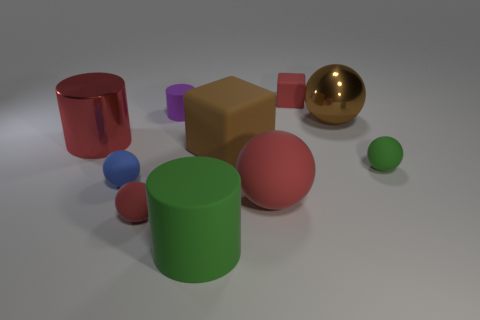There is a green matte object that is on the left side of the matte block that is in front of the big red cylinder; what is its size?
Your response must be concise. Large. Is there another matte sphere that has the same color as the large matte sphere?
Your response must be concise. Yes. Are there the same number of small matte cylinders that are in front of the purple matte cylinder and small red balls?
Provide a succinct answer. No. What number of rubber cubes are there?
Provide a succinct answer. 2. What shape is the big thing that is both in front of the red metal thing and on the left side of the large brown matte thing?
Provide a short and direct response. Cylinder. There is a metallic object that is to the right of the blue rubber sphere; is its color the same as the tiny ball that is right of the small purple cylinder?
Offer a very short reply. No. What is the size of the cube that is the same color as the big metallic cylinder?
Your answer should be very brief. Small. Is there a brown ball made of the same material as the green cylinder?
Make the answer very short. No. Are there an equal number of purple cylinders behind the red shiny cylinder and red metallic cylinders that are on the right side of the blue ball?
Make the answer very short. No. What is the size of the red sphere left of the large green cylinder?
Your answer should be very brief. Small. 